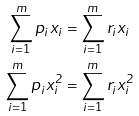Convert formula to latex. <formula><loc_0><loc_0><loc_500><loc_500>\sum _ { i = 1 } ^ { m } p _ { i } x _ { i } & = \sum _ { i = 1 } ^ { m } r _ { i } x _ { i } \\ \sum _ { i = 1 } ^ { m } p _ { i } x _ { i } ^ { 2 } & = \sum _ { i = 1 } ^ { m } r _ { i } x _ { i } ^ { 2 }</formula> 